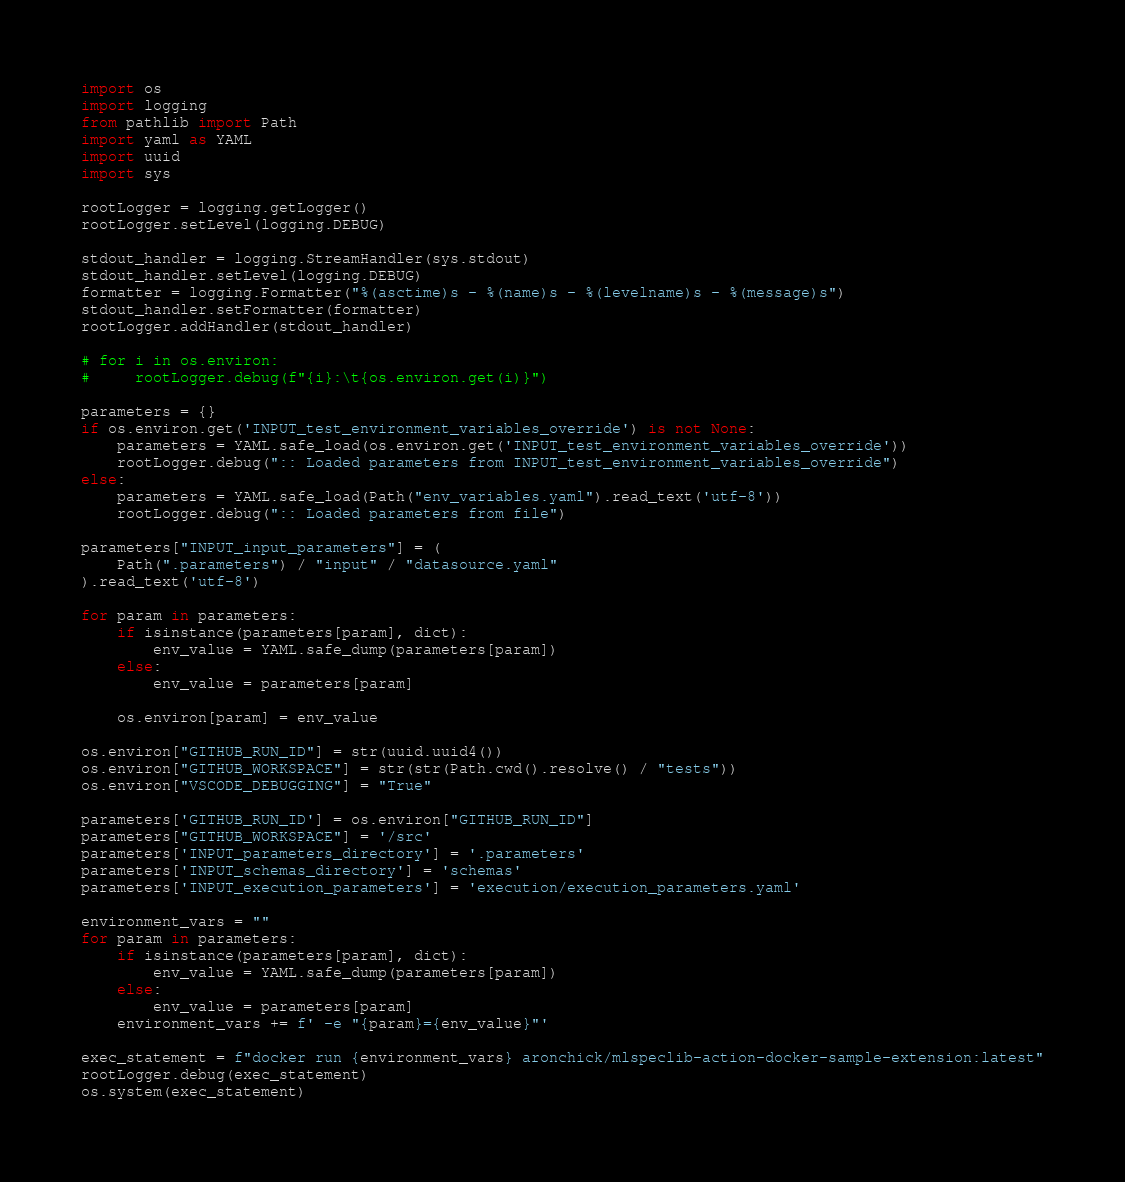Convert code to text. <code><loc_0><loc_0><loc_500><loc_500><_Python_>import os
import logging
from pathlib import Path
import yaml as YAML
import uuid
import sys

rootLogger = logging.getLogger()
rootLogger.setLevel(logging.DEBUG)

stdout_handler = logging.StreamHandler(sys.stdout)
stdout_handler.setLevel(logging.DEBUG)
formatter = logging.Formatter("%(asctime)s - %(name)s - %(levelname)s - %(message)s")
stdout_handler.setFormatter(formatter)
rootLogger.addHandler(stdout_handler)

# for i in os.environ:
#     rootLogger.debug(f"{i}:\t{os.environ.get(i)}")

parameters = {}
if os.environ.get('INPUT_test_environment_variables_override') is not None:
    parameters = YAML.safe_load(os.environ.get('INPUT_test_environment_variables_override'))
    rootLogger.debug(":: Loaded parameters from INPUT_test_environment_variables_override")
else:
    parameters = YAML.safe_load(Path("env_variables.yaml").read_text('utf-8'))
    rootLogger.debug(":: Loaded parameters from file")

parameters["INPUT_input_parameters"] = (
    Path(".parameters") / "input" / "datasource.yaml"
).read_text('utf-8')

for param in parameters:
    if isinstance(parameters[param], dict):
        env_value = YAML.safe_dump(parameters[param])
    else:
        env_value = parameters[param]

    os.environ[param] = env_value

os.environ["GITHUB_RUN_ID"] = str(uuid.uuid4())
os.environ["GITHUB_WORKSPACE"] = str(str(Path.cwd().resolve() / "tests"))
os.environ["VSCODE_DEBUGGING"] = "True"

parameters['GITHUB_RUN_ID'] = os.environ["GITHUB_RUN_ID"]
parameters["GITHUB_WORKSPACE"] = '/src'
parameters['INPUT_parameters_directory'] = '.parameters'
parameters['INPUT_schemas_directory'] = 'schemas'
parameters['INPUT_execution_parameters'] = 'execution/execution_parameters.yaml'

environment_vars = ""
for param in parameters:
    if isinstance(parameters[param], dict):
        env_value = YAML.safe_dump(parameters[param])
    else:
        env_value = parameters[param]
    environment_vars += f' -e "{param}={env_value}"'

exec_statement = f"docker run {environment_vars} aronchick/mlspeclib-action-docker-sample-extension:latest"
rootLogger.debug(exec_statement)
os.system(exec_statement)
</code> 